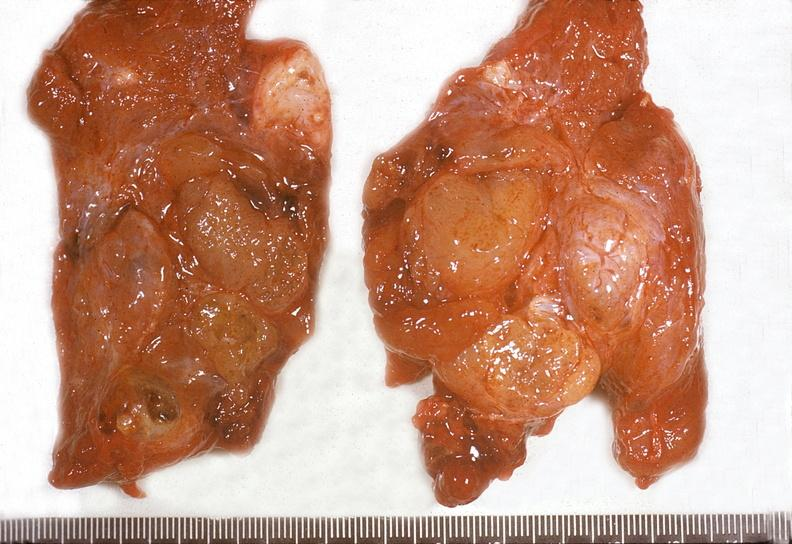does this image show thyroid, adenomatous goiter?
Answer the question using a single word or phrase. Yes 